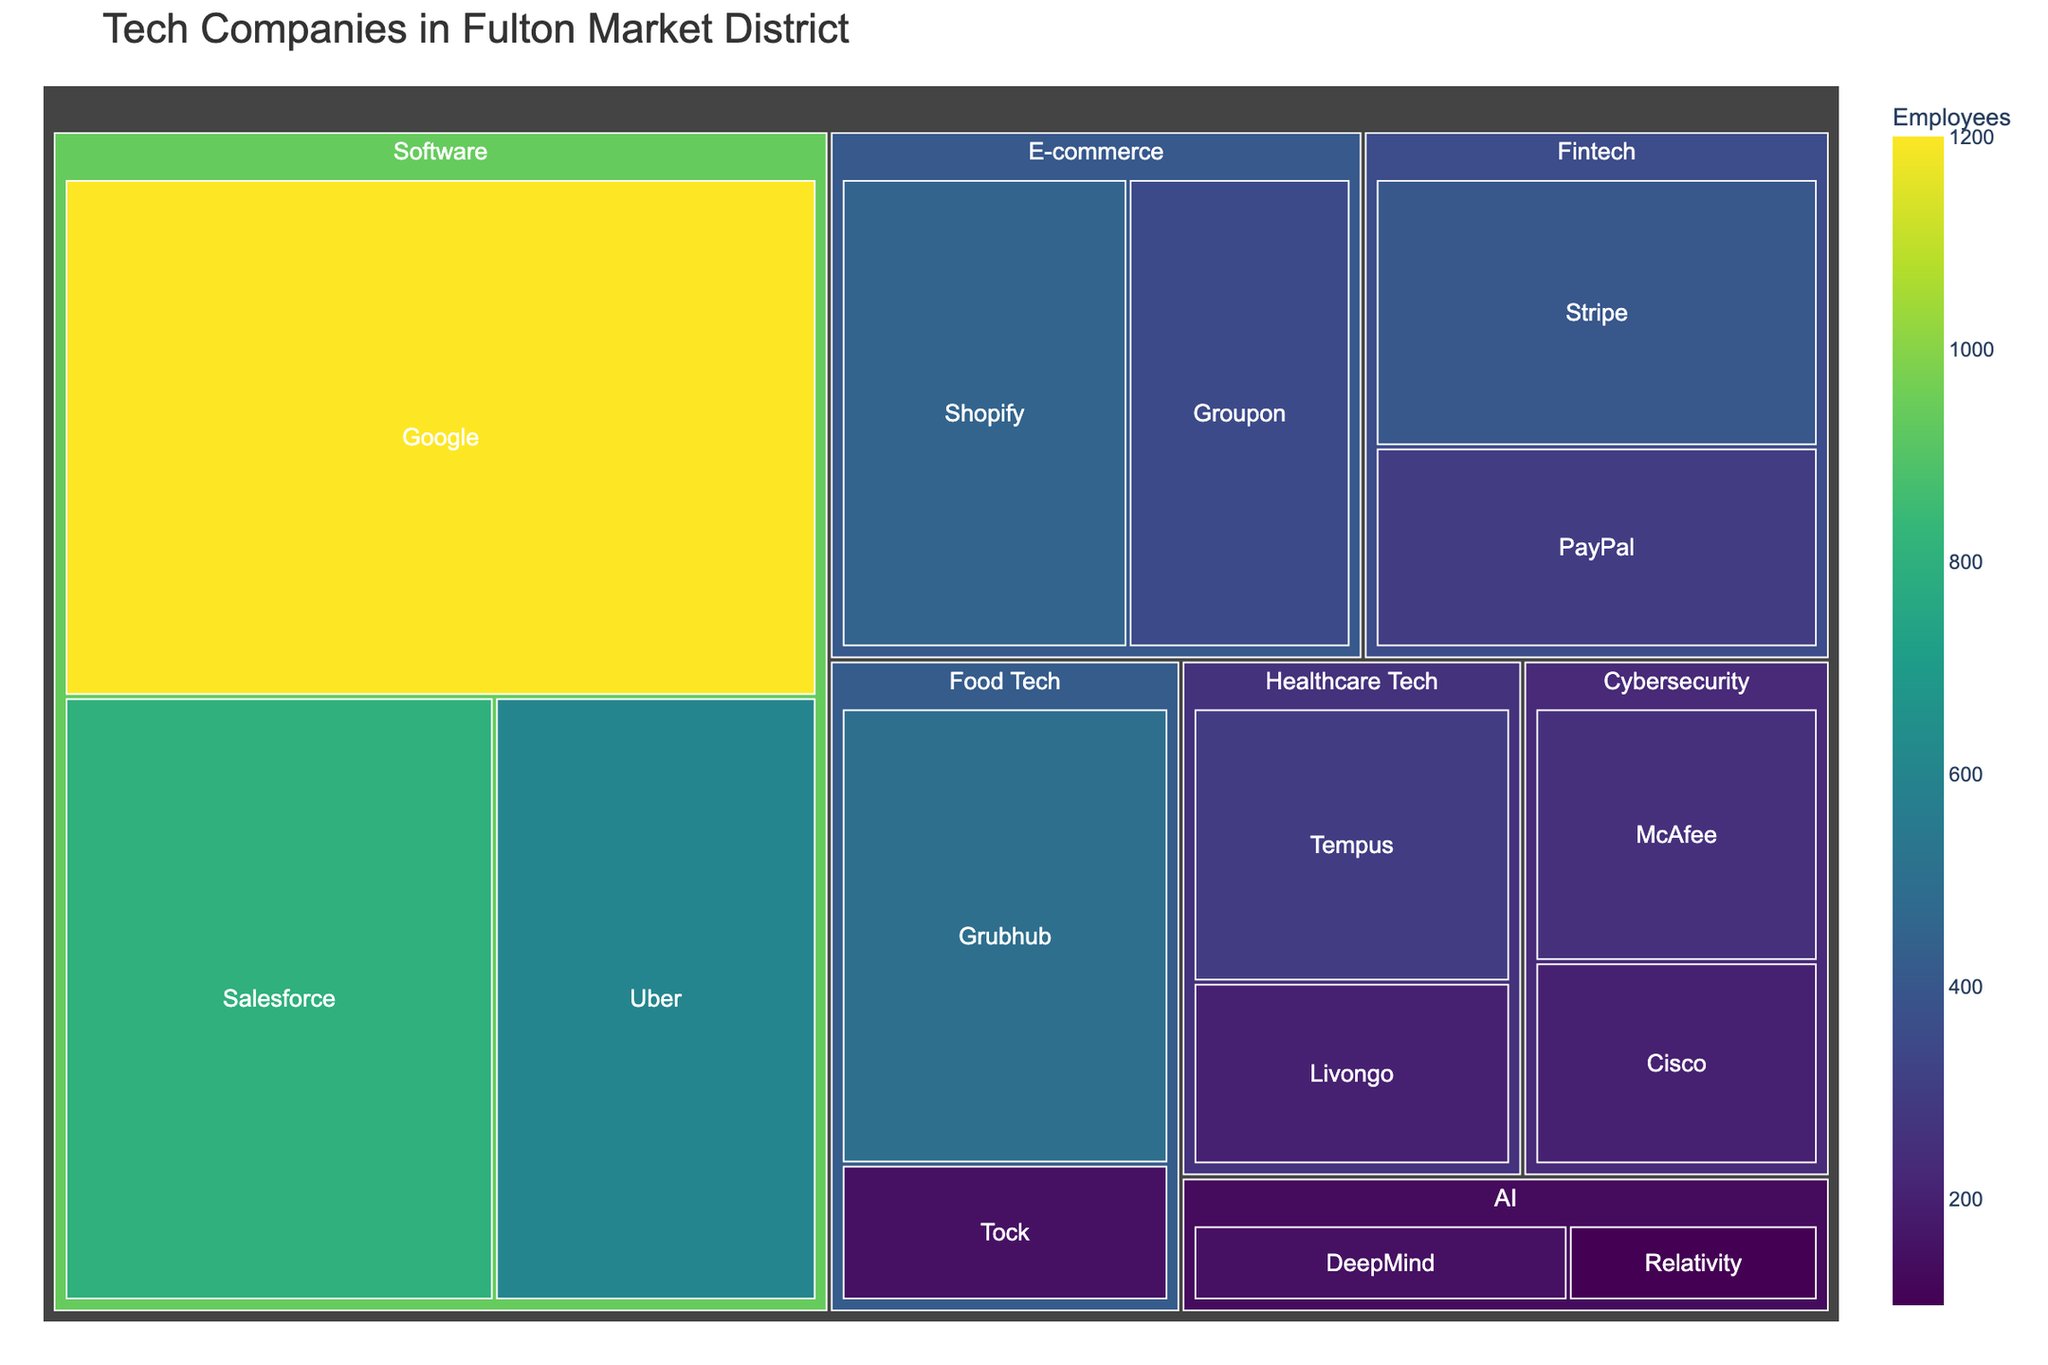What is the title of the figure? The title is usually located at the top of the figure, and it gives an overview of what the figure is about. By reading the title directly from the figure, we see that it states the following:
Answer: Tech Companies in Fulton Market District Which sector has the largest representation by employee count? By observing the size of the blocks for each sector in the treemap, the largest block indicates the sector with the highest employee count. The Software sector, including Google, Salesforce, and Uber, appears to have the largest combined size.
Answer: Software Which company in the Food Tech sector has the most employees? Within the Food Tech sector, compare the sizes and employee counts displayed for each company. Grubhub has a larger block and higher employee count compared to Tock.
Answer: Grubhub What is the total number of employees in the E-commerce sector? Add the employee counts for all companies in the E-commerce sector. The companies Shopify and Groupon have 450 and 350 employees respectively, making the total: 450 + 350.
Answer: 800 Which AI company has fewer employees? Compare the sizes and employee counts of the blocks under the AI sector. DeepMind has 150 employees, while Relativity has 100.
Answer: Relativity How many companies have more than 500 employees? Scan the blocks and identify companies with employee counts greater than 500. Google (1200), Salesforce (800), Uber (600), and Grubhub (500) meet this criterion, making four companies.
Answer: 4 What is the sum of employees in the Cybersecurity sector? Combine the employee numbers for McAfee and Cisco in the Cybersecurity sector. McAfee has 250 and Cisco has 200, so: 250 + 200.
Answer: 450 Which sector has the smallest number of employees? Determine which sector has the smallest total size by summing up the employees within each sector and identifying the sector with the smallest sum. The AI sector has 250 employees (DeepMind 150 + Relativity 100), which is smaller than other sectors.
Answer: AI What is the average number of employees per company in the Healthcare Tech sector? Healthcare Tech has Tempus with 300 employees and Livongo with 200 employees. To find the average, sum these values and divide by the number of companies: (300 + 200) / 2.
Answer: 250 Which Software company has the second largest number of employees? In the Software sector, compare the employee counts: Google (1200), Salesforce (800), Uber (600). The second largest is Salesforce.
Answer: Salesforce 